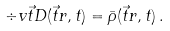Convert formula to latex. <formula><loc_0><loc_0><loc_500><loc_500>\div v \vec { t } { D } ( \vec { t } { r } , t ) = \bar { \rho } ( \vec { t } { r } , t ) \, .</formula> 